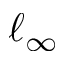<formula> <loc_0><loc_0><loc_500><loc_500>\ell _ { \infty }</formula> 